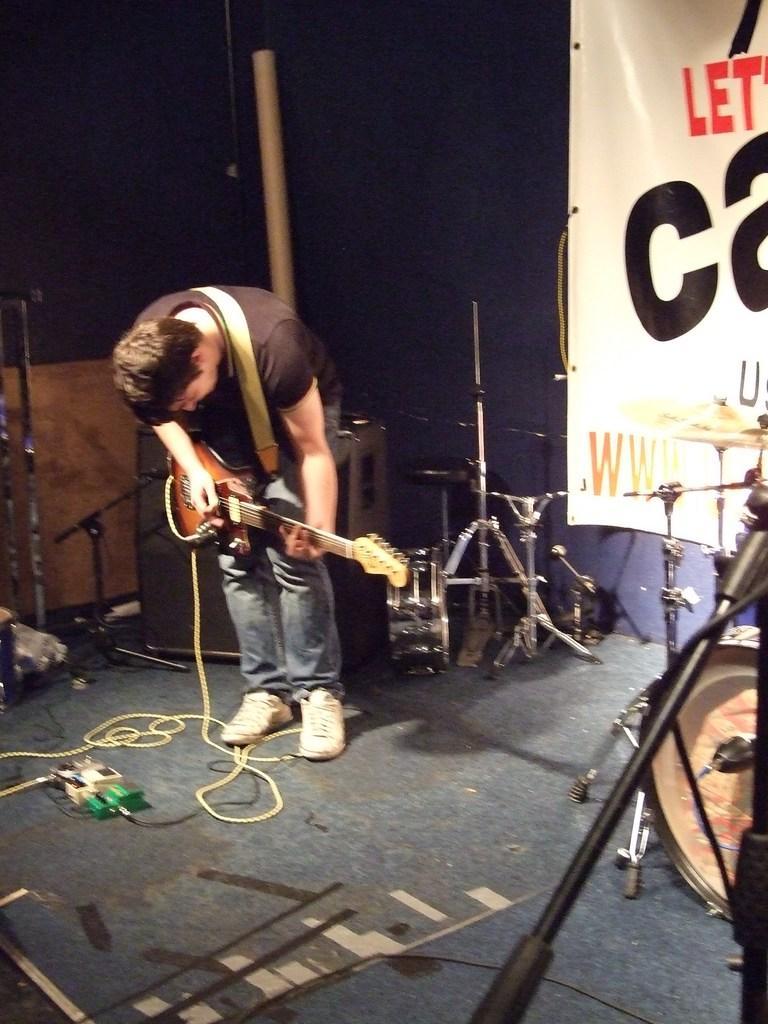Could you give a brief overview of what you see in this image? In this image I can see a man is playing a guitar on stage. I can also see there is other musical instruments on it. 